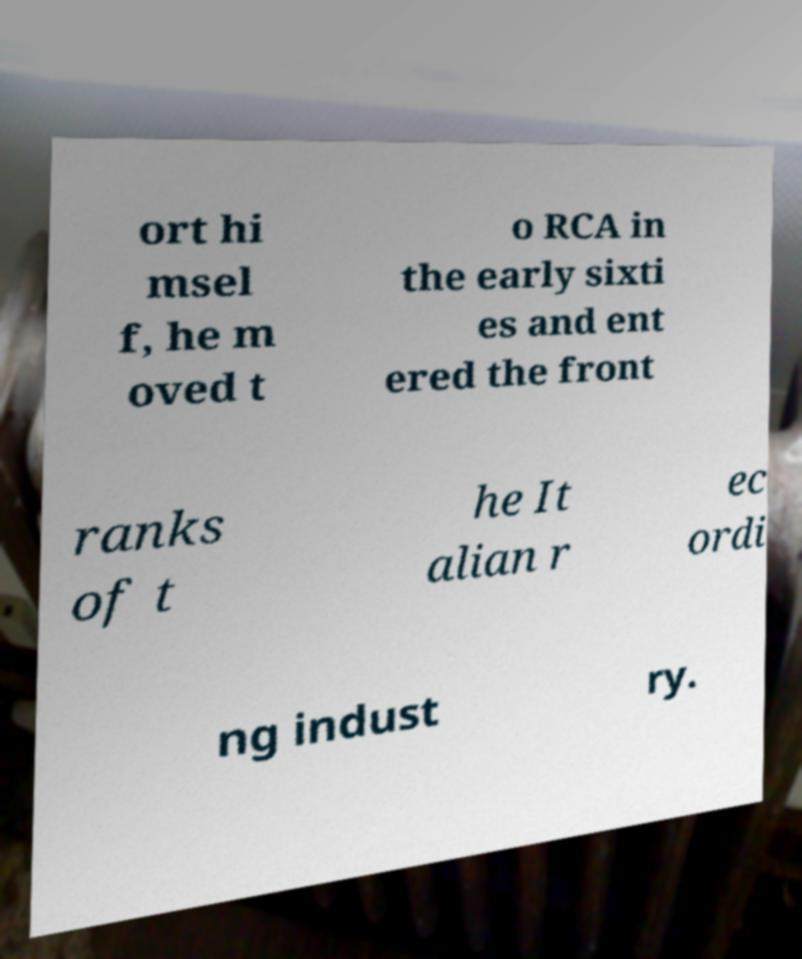There's text embedded in this image that I need extracted. Can you transcribe it verbatim? ort hi msel f, he m oved t o RCA in the early sixti es and ent ered the front ranks of t he It alian r ec ordi ng indust ry. 